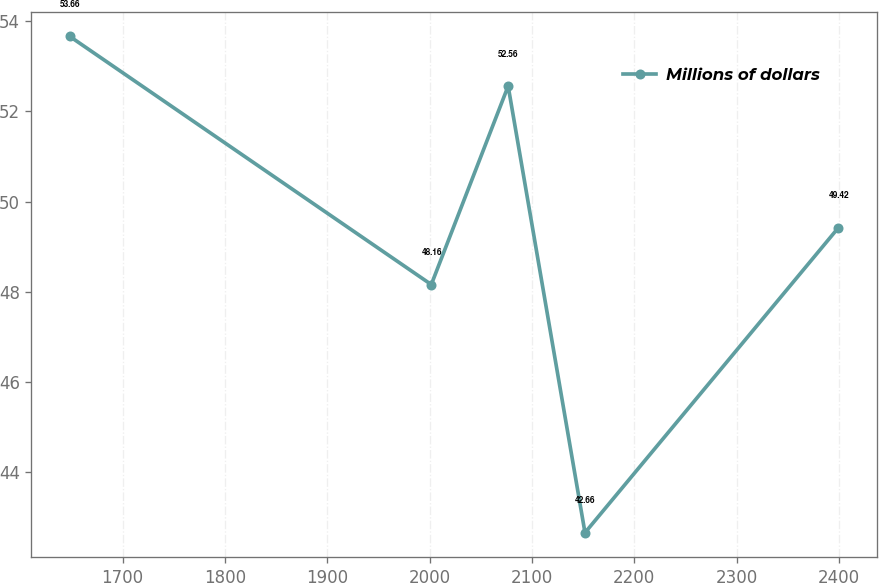<chart> <loc_0><loc_0><loc_500><loc_500><line_chart><ecel><fcel>Millions of dollars<nl><fcel>1648.4<fcel>53.66<nl><fcel>2001.64<fcel>48.16<nl><fcel>2076.75<fcel>52.56<nl><fcel>2151.86<fcel>42.66<nl><fcel>2399.49<fcel>49.42<nl></chart> 